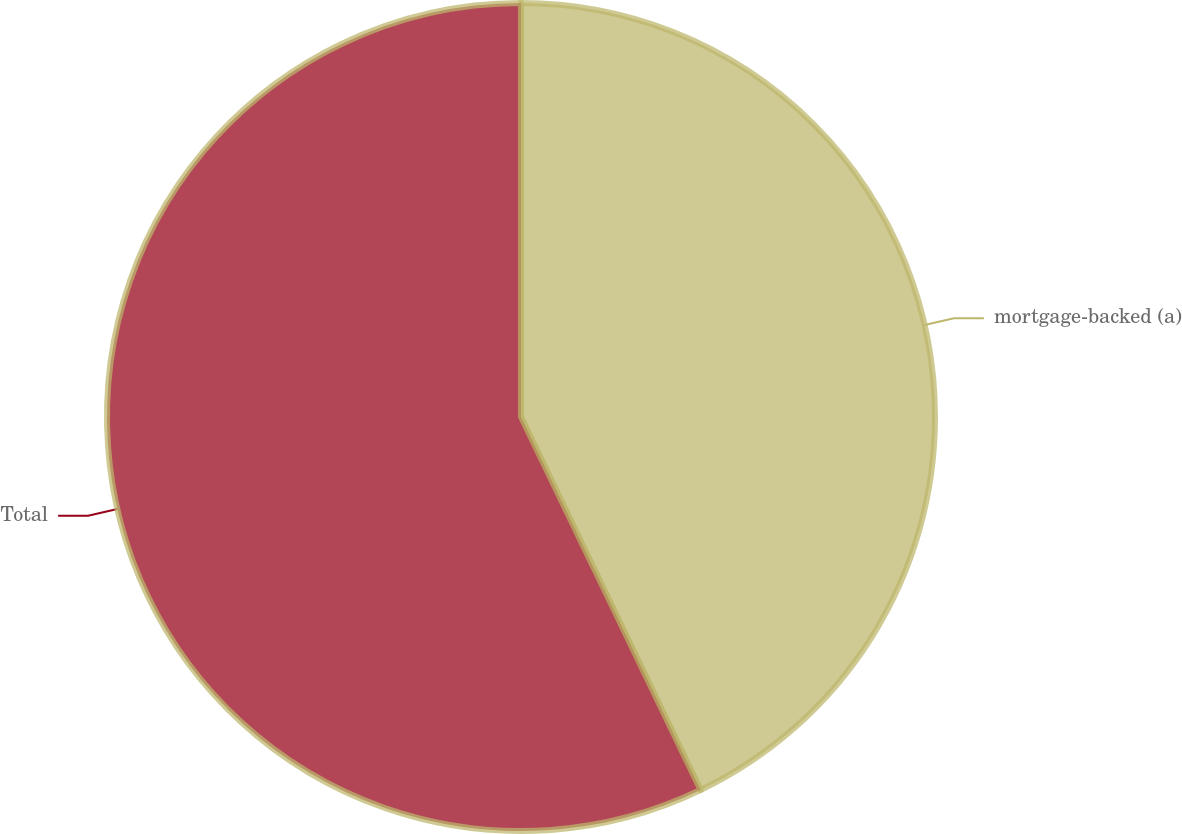<chart> <loc_0><loc_0><loc_500><loc_500><pie_chart><fcel>mortgage-backed (a)<fcel>Total<nl><fcel>42.86%<fcel>57.14%<nl></chart> 